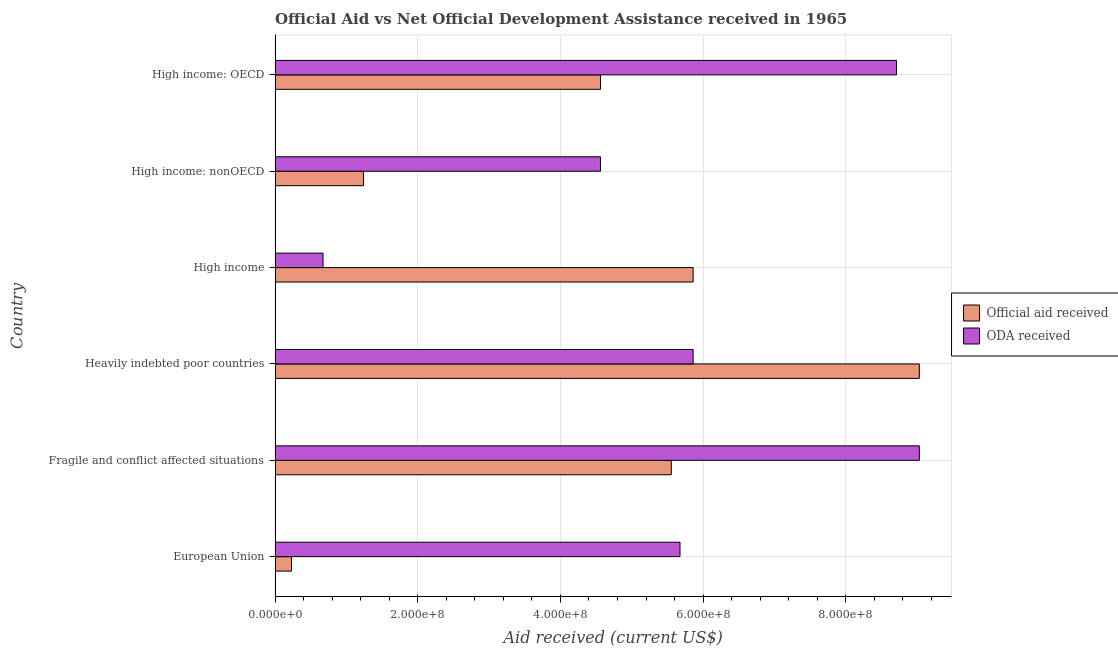How many different coloured bars are there?
Your response must be concise. 2. How many bars are there on the 4th tick from the top?
Make the answer very short. 2. How many bars are there on the 3rd tick from the bottom?
Make the answer very short. 2. What is the label of the 2nd group of bars from the top?
Offer a terse response. High income: nonOECD. In how many cases, is the number of bars for a given country not equal to the number of legend labels?
Your answer should be compact. 0. What is the official aid received in European Union?
Make the answer very short. 2.30e+07. Across all countries, what is the maximum official aid received?
Provide a short and direct response. 9.03e+08. Across all countries, what is the minimum oda received?
Your answer should be compact. 6.72e+07. In which country was the oda received maximum?
Ensure brevity in your answer.  Fragile and conflict affected situations. In which country was the official aid received minimum?
Your answer should be compact. European Union. What is the total official aid received in the graph?
Keep it short and to the point. 2.65e+09. What is the difference between the official aid received in European Union and that in High income?
Your answer should be very brief. -5.63e+08. What is the difference between the oda received in High income: OECD and the official aid received in European Union?
Make the answer very short. 8.48e+08. What is the average official aid received per country?
Keep it short and to the point. 4.41e+08. What is the difference between the official aid received and oda received in Heavily indebted poor countries?
Your answer should be very brief. 3.17e+08. In how many countries, is the oda received greater than 480000000 US$?
Provide a short and direct response. 4. What is the ratio of the oda received in European Union to that in Fragile and conflict affected situations?
Provide a succinct answer. 0.63. Is the oda received in European Union less than that in High income: OECD?
Offer a very short reply. Yes. What is the difference between the highest and the second highest official aid received?
Make the answer very short. 3.17e+08. What is the difference between the highest and the lowest oda received?
Provide a short and direct response. 8.36e+08. In how many countries, is the oda received greater than the average oda received taken over all countries?
Make the answer very short. 3. What does the 2nd bar from the top in High income: nonOECD represents?
Your answer should be very brief. Official aid received. What does the 2nd bar from the bottom in High income: nonOECD represents?
Make the answer very short. ODA received. How many countries are there in the graph?
Your answer should be compact. 6. What is the difference between two consecutive major ticks on the X-axis?
Offer a very short reply. 2.00e+08. Does the graph contain grids?
Provide a succinct answer. Yes. Where does the legend appear in the graph?
Make the answer very short. Center right. What is the title of the graph?
Provide a succinct answer. Official Aid vs Net Official Development Assistance received in 1965 . What is the label or title of the X-axis?
Ensure brevity in your answer.  Aid received (current US$). What is the label or title of the Y-axis?
Your answer should be compact. Country. What is the Aid received (current US$) in Official aid received in European Union?
Your response must be concise. 2.30e+07. What is the Aid received (current US$) of ODA received in European Union?
Your answer should be very brief. 5.68e+08. What is the Aid received (current US$) of Official aid received in Fragile and conflict affected situations?
Ensure brevity in your answer.  5.55e+08. What is the Aid received (current US$) of ODA received in Fragile and conflict affected situations?
Offer a terse response. 9.03e+08. What is the Aid received (current US$) in Official aid received in Heavily indebted poor countries?
Keep it short and to the point. 9.03e+08. What is the Aid received (current US$) of ODA received in Heavily indebted poor countries?
Your response must be concise. 5.86e+08. What is the Aid received (current US$) in Official aid received in High income?
Provide a short and direct response. 5.86e+08. What is the Aid received (current US$) in ODA received in High income?
Provide a succinct answer. 6.72e+07. What is the Aid received (current US$) of Official aid received in High income: nonOECD?
Your response must be concise. 1.24e+08. What is the Aid received (current US$) of ODA received in High income: nonOECD?
Make the answer very short. 4.56e+08. What is the Aid received (current US$) in Official aid received in High income: OECD?
Offer a very short reply. 4.56e+08. What is the Aid received (current US$) of ODA received in High income: OECD?
Offer a very short reply. 8.71e+08. Across all countries, what is the maximum Aid received (current US$) of Official aid received?
Offer a very short reply. 9.03e+08. Across all countries, what is the maximum Aid received (current US$) of ODA received?
Your answer should be very brief. 9.03e+08. Across all countries, what is the minimum Aid received (current US$) of Official aid received?
Provide a short and direct response. 2.30e+07. Across all countries, what is the minimum Aid received (current US$) in ODA received?
Offer a terse response. 6.72e+07. What is the total Aid received (current US$) of Official aid received in the graph?
Provide a short and direct response. 2.65e+09. What is the total Aid received (current US$) in ODA received in the graph?
Your answer should be very brief. 3.45e+09. What is the difference between the Aid received (current US$) of Official aid received in European Union and that in Fragile and conflict affected situations?
Ensure brevity in your answer.  -5.32e+08. What is the difference between the Aid received (current US$) in ODA received in European Union and that in Fragile and conflict affected situations?
Make the answer very short. -3.36e+08. What is the difference between the Aid received (current US$) of Official aid received in European Union and that in Heavily indebted poor countries?
Provide a succinct answer. -8.80e+08. What is the difference between the Aid received (current US$) of ODA received in European Union and that in Heavily indebted poor countries?
Offer a terse response. -1.84e+07. What is the difference between the Aid received (current US$) of Official aid received in European Union and that in High income?
Your answer should be compact. -5.63e+08. What is the difference between the Aid received (current US$) of ODA received in European Union and that in High income?
Your response must be concise. 5.00e+08. What is the difference between the Aid received (current US$) in Official aid received in European Union and that in High income: nonOECD?
Your response must be concise. -1.01e+08. What is the difference between the Aid received (current US$) of ODA received in European Union and that in High income: nonOECD?
Offer a very short reply. 1.11e+08. What is the difference between the Aid received (current US$) of Official aid received in European Union and that in High income: OECD?
Your response must be concise. -4.33e+08. What is the difference between the Aid received (current US$) in ODA received in European Union and that in High income: OECD?
Give a very brief answer. -3.04e+08. What is the difference between the Aid received (current US$) in Official aid received in Fragile and conflict affected situations and that in Heavily indebted poor countries?
Give a very brief answer. -3.48e+08. What is the difference between the Aid received (current US$) of ODA received in Fragile and conflict affected situations and that in Heavily indebted poor countries?
Your answer should be compact. 3.17e+08. What is the difference between the Aid received (current US$) in Official aid received in Fragile and conflict affected situations and that in High income?
Make the answer very short. -3.06e+07. What is the difference between the Aid received (current US$) of ODA received in Fragile and conflict affected situations and that in High income?
Your response must be concise. 8.36e+08. What is the difference between the Aid received (current US$) in Official aid received in Fragile and conflict affected situations and that in High income: nonOECD?
Give a very brief answer. 4.31e+08. What is the difference between the Aid received (current US$) in ODA received in Fragile and conflict affected situations and that in High income: nonOECD?
Provide a succinct answer. 4.47e+08. What is the difference between the Aid received (current US$) in Official aid received in Fragile and conflict affected situations and that in High income: OECD?
Your response must be concise. 9.93e+07. What is the difference between the Aid received (current US$) in ODA received in Fragile and conflict affected situations and that in High income: OECD?
Your answer should be compact. 3.20e+07. What is the difference between the Aid received (current US$) of Official aid received in Heavily indebted poor countries and that in High income?
Your answer should be very brief. 3.17e+08. What is the difference between the Aid received (current US$) of ODA received in Heavily indebted poor countries and that in High income?
Your answer should be compact. 5.19e+08. What is the difference between the Aid received (current US$) in Official aid received in Heavily indebted poor countries and that in High income: nonOECD?
Offer a very short reply. 7.79e+08. What is the difference between the Aid received (current US$) of ODA received in Heavily indebted poor countries and that in High income: nonOECD?
Your answer should be very brief. 1.30e+08. What is the difference between the Aid received (current US$) in Official aid received in Heavily indebted poor countries and that in High income: OECD?
Your answer should be very brief. 4.47e+08. What is the difference between the Aid received (current US$) in ODA received in Heavily indebted poor countries and that in High income: OECD?
Your response must be concise. -2.85e+08. What is the difference between the Aid received (current US$) of Official aid received in High income and that in High income: nonOECD?
Ensure brevity in your answer.  4.62e+08. What is the difference between the Aid received (current US$) of ODA received in High income and that in High income: nonOECD?
Provide a short and direct response. -3.89e+08. What is the difference between the Aid received (current US$) of Official aid received in High income and that in High income: OECD?
Your response must be concise. 1.30e+08. What is the difference between the Aid received (current US$) of ODA received in High income and that in High income: OECD?
Offer a very short reply. -8.04e+08. What is the difference between the Aid received (current US$) in Official aid received in High income: nonOECD and that in High income: OECD?
Provide a short and direct response. -3.32e+08. What is the difference between the Aid received (current US$) in ODA received in High income: nonOECD and that in High income: OECD?
Keep it short and to the point. -4.15e+08. What is the difference between the Aid received (current US$) of Official aid received in European Union and the Aid received (current US$) of ODA received in Fragile and conflict affected situations?
Ensure brevity in your answer.  -8.80e+08. What is the difference between the Aid received (current US$) in Official aid received in European Union and the Aid received (current US$) in ODA received in Heavily indebted poor countries?
Provide a succinct answer. -5.63e+08. What is the difference between the Aid received (current US$) of Official aid received in European Union and the Aid received (current US$) of ODA received in High income?
Keep it short and to the point. -4.42e+07. What is the difference between the Aid received (current US$) of Official aid received in European Union and the Aid received (current US$) of ODA received in High income: nonOECD?
Offer a very short reply. -4.33e+08. What is the difference between the Aid received (current US$) in Official aid received in European Union and the Aid received (current US$) in ODA received in High income: OECD?
Offer a terse response. -8.48e+08. What is the difference between the Aid received (current US$) of Official aid received in Fragile and conflict affected situations and the Aid received (current US$) of ODA received in Heavily indebted poor countries?
Provide a short and direct response. -3.06e+07. What is the difference between the Aid received (current US$) of Official aid received in Fragile and conflict affected situations and the Aid received (current US$) of ODA received in High income?
Provide a short and direct response. 4.88e+08. What is the difference between the Aid received (current US$) of Official aid received in Fragile and conflict affected situations and the Aid received (current US$) of ODA received in High income: nonOECD?
Your answer should be very brief. 9.93e+07. What is the difference between the Aid received (current US$) in Official aid received in Fragile and conflict affected situations and the Aid received (current US$) in ODA received in High income: OECD?
Your response must be concise. -3.16e+08. What is the difference between the Aid received (current US$) of Official aid received in Heavily indebted poor countries and the Aid received (current US$) of ODA received in High income?
Provide a succinct answer. 8.36e+08. What is the difference between the Aid received (current US$) of Official aid received in Heavily indebted poor countries and the Aid received (current US$) of ODA received in High income: nonOECD?
Offer a very short reply. 4.47e+08. What is the difference between the Aid received (current US$) of Official aid received in Heavily indebted poor countries and the Aid received (current US$) of ODA received in High income: OECD?
Your answer should be very brief. 3.20e+07. What is the difference between the Aid received (current US$) in Official aid received in High income and the Aid received (current US$) in ODA received in High income: nonOECD?
Ensure brevity in your answer.  1.30e+08. What is the difference between the Aid received (current US$) of Official aid received in High income and the Aid received (current US$) of ODA received in High income: OECD?
Ensure brevity in your answer.  -2.85e+08. What is the difference between the Aid received (current US$) in Official aid received in High income: nonOECD and the Aid received (current US$) in ODA received in High income: OECD?
Provide a short and direct response. -7.47e+08. What is the average Aid received (current US$) of Official aid received per country?
Your answer should be very brief. 4.41e+08. What is the average Aid received (current US$) in ODA received per country?
Your answer should be compact. 5.75e+08. What is the difference between the Aid received (current US$) of Official aid received and Aid received (current US$) of ODA received in European Union?
Offer a very short reply. -5.45e+08. What is the difference between the Aid received (current US$) of Official aid received and Aid received (current US$) of ODA received in Fragile and conflict affected situations?
Make the answer very short. -3.48e+08. What is the difference between the Aid received (current US$) in Official aid received and Aid received (current US$) in ODA received in Heavily indebted poor countries?
Make the answer very short. 3.17e+08. What is the difference between the Aid received (current US$) in Official aid received and Aid received (current US$) in ODA received in High income?
Keep it short and to the point. 5.19e+08. What is the difference between the Aid received (current US$) in Official aid received and Aid received (current US$) in ODA received in High income: nonOECD?
Your answer should be compact. -3.32e+08. What is the difference between the Aid received (current US$) in Official aid received and Aid received (current US$) in ODA received in High income: OECD?
Your response must be concise. -4.15e+08. What is the ratio of the Aid received (current US$) of Official aid received in European Union to that in Fragile and conflict affected situations?
Make the answer very short. 0.04. What is the ratio of the Aid received (current US$) in ODA received in European Union to that in Fragile and conflict affected situations?
Make the answer very short. 0.63. What is the ratio of the Aid received (current US$) of Official aid received in European Union to that in Heavily indebted poor countries?
Keep it short and to the point. 0.03. What is the ratio of the Aid received (current US$) of ODA received in European Union to that in Heavily indebted poor countries?
Give a very brief answer. 0.97. What is the ratio of the Aid received (current US$) of Official aid received in European Union to that in High income?
Keep it short and to the point. 0.04. What is the ratio of the Aid received (current US$) in ODA received in European Union to that in High income?
Make the answer very short. 8.44. What is the ratio of the Aid received (current US$) of Official aid received in European Union to that in High income: nonOECD?
Offer a very short reply. 0.19. What is the ratio of the Aid received (current US$) in ODA received in European Union to that in High income: nonOECD?
Ensure brevity in your answer.  1.24. What is the ratio of the Aid received (current US$) of Official aid received in European Union to that in High income: OECD?
Ensure brevity in your answer.  0.05. What is the ratio of the Aid received (current US$) in ODA received in European Union to that in High income: OECD?
Provide a succinct answer. 0.65. What is the ratio of the Aid received (current US$) of Official aid received in Fragile and conflict affected situations to that in Heavily indebted poor countries?
Provide a short and direct response. 0.61. What is the ratio of the Aid received (current US$) of ODA received in Fragile and conflict affected situations to that in Heavily indebted poor countries?
Make the answer very short. 1.54. What is the ratio of the Aid received (current US$) of Official aid received in Fragile and conflict affected situations to that in High income?
Make the answer very short. 0.95. What is the ratio of the Aid received (current US$) of ODA received in Fragile and conflict affected situations to that in High income?
Keep it short and to the point. 13.44. What is the ratio of the Aid received (current US$) in Official aid received in Fragile and conflict affected situations to that in High income: nonOECD?
Make the answer very short. 4.48. What is the ratio of the Aid received (current US$) of ODA received in Fragile and conflict affected situations to that in High income: nonOECD?
Offer a very short reply. 1.98. What is the ratio of the Aid received (current US$) in Official aid received in Fragile and conflict affected situations to that in High income: OECD?
Provide a succinct answer. 1.22. What is the ratio of the Aid received (current US$) of ODA received in Fragile and conflict affected situations to that in High income: OECD?
Your answer should be very brief. 1.04. What is the ratio of the Aid received (current US$) in Official aid received in Heavily indebted poor countries to that in High income?
Make the answer very short. 1.54. What is the ratio of the Aid received (current US$) of ODA received in Heavily indebted poor countries to that in High income?
Ensure brevity in your answer.  8.72. What is the ratio of the Aid received (current US$) in Official aid received in Heavily indebted poor countries to that in High income: nonOECD?
Ensure brevity in your answer.  7.28. What is the ratio of the Aid received (current US$) of ODA received in Heavily indebted poor countries to that in High income: nonOECD?
Give a very brief answer. 1.28. What is the ratio of the Aid received (current US$) of Official aid received in Heavily indebted poor countries to that in High income: OECD?
Make the answer very short. 1.98. What is the ratio of the Aid received (current US$) of ODA received in Heavily indebted poor countries to that in High income: OECD?
Provide a succinct answer. 0.67. What is the ratio of the Aid received (current US$) in Official aid received in High income to that in High income: nonOECD?
Offer a very short reply. 4.72. What is the ratio of the Aid received (current US$) of ODA received in High income to that in High income: nonOECD?
Your answer should be very brief. 0.15. What is the ratio of the Aid received (current US$) in Official aid received in High income to that in High income: OECD?
Provide a short and direct response. 1.28. What is the ratio of the Aid received (current US$) of ODA received in High income to that in High income: OECD?
Offer a terse response. 0.08. What is the ratio of the Aid received (current US$) in Official aid received in High income: nonOECD to that in High income: OECD?
Offer a very short reply. 0.27. What is the ratio of the Aid received (current US$) in ODA received in High income: nonOECD to that in High income: OECD?
Provide a succinct answer. 0.52. What is the difference between the highest and the second highest Aid received (current US$) of Official aid received?
Provide a succinct answer. 3.17e+08. What is the difference between the highest and the second highest Aid received (current US$) in ODA received?
Your answer should be very brief. 3.20e+07. What is the difference between the highest and the lowest Aid received (current US$) of Official aid received?
Offer a very short reply. 8.80e+08. What is the difference between the highest and the lowest Aid received (current US$) of ODA received?
Your response must be concise. 8.36e+08. 